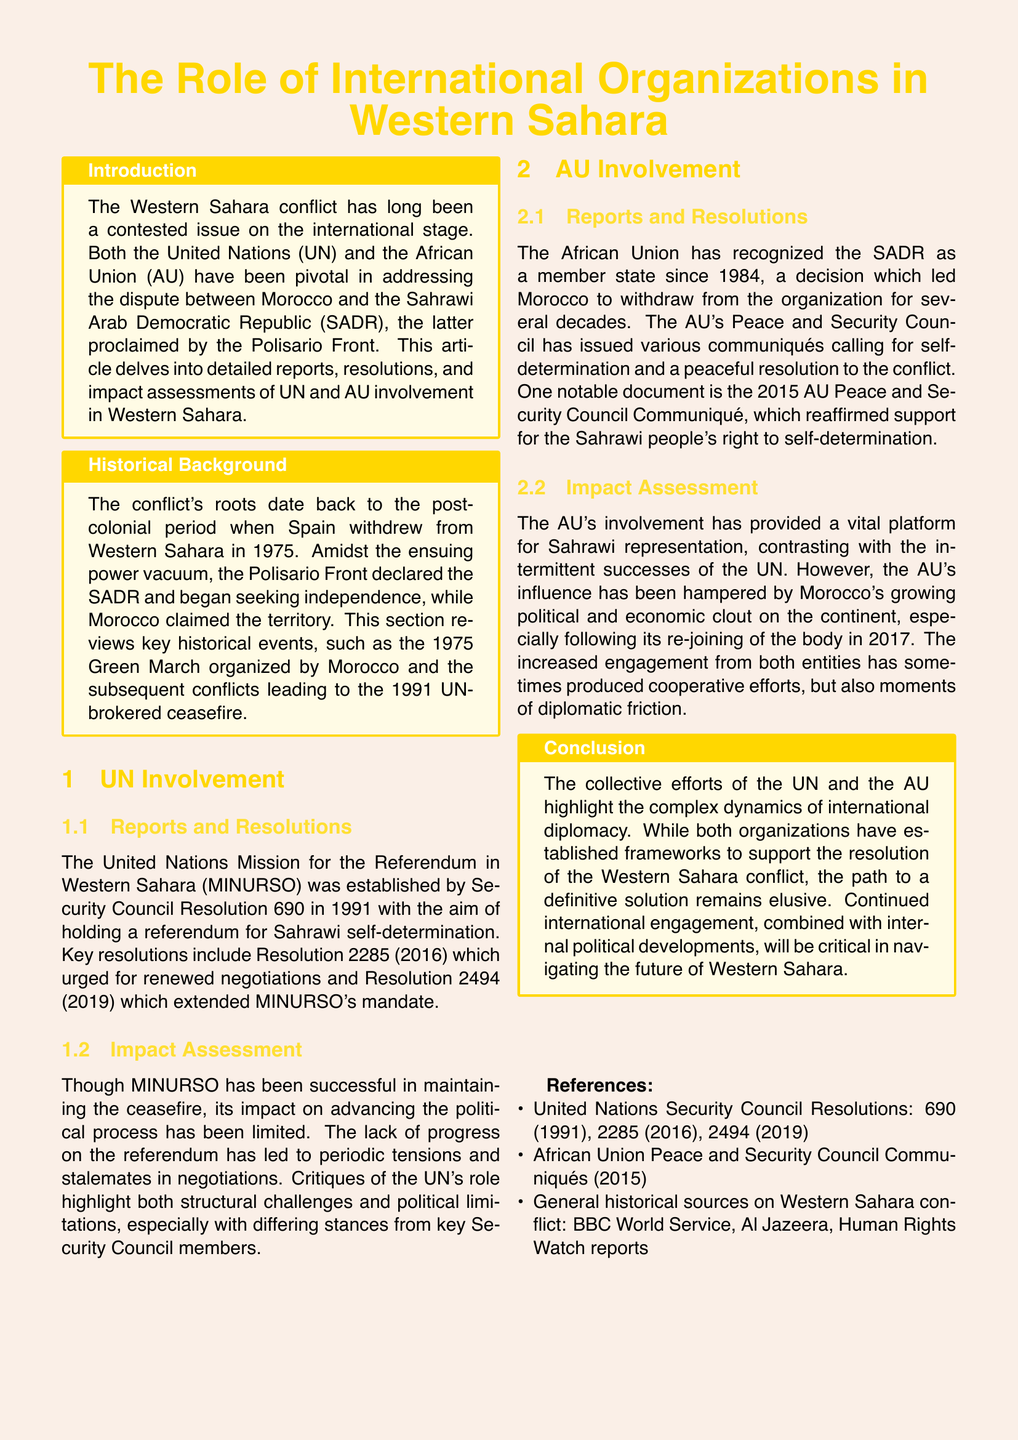What is the main focus of the article? The article focuses on the role of international organizations, specifically the UN and AU, in the Western Sahara conflict.
Answer: The role of international organizations in Western Sahara What resolution established the United Nations Mission for the Referendum in Western Sahara? Resolution 690 established MINURSO in 1991.
Answer: Resolution 690 When did the African Union recognize the SADR as a member state? The AU recognized the SADR as a member state in 1984.
Answer: 1984 What is one key critique of the UN's involvement in Western Sahara? The UN's progress on the referendum has been limited and led to tensions and stalemates in negotiations.
Answer: Limited progress on the referendum What document reaffirmed support for the Sahrawi people's right to self-determination? The 2015 AU Peace and Security Council Communiqué reaffirmed this support.
Answer: 2015 AU Peace and Security Council Communiqué What event led to Morocco's withdrawal from the African Union for several decades? Morocco withdrew due to the AU recognizing the SADR as a member state.
Answer: Recognition of the SADR Which two major organizations are compared in the document? The document compares the United Nations (UN) and the African Union (AU) regarding their involvement.
Answer: United Nations and African Union What has been a positive outcome of the AU's involvement? The AU has provided a vital platform for Sahrawi representation.
Answer: Vital platform for Sahrawi representation What remains critical for the future of Western Sahara according to the conclusion? Continued international engagement and internal political developments are critical.
Answer: Continued international engagement 